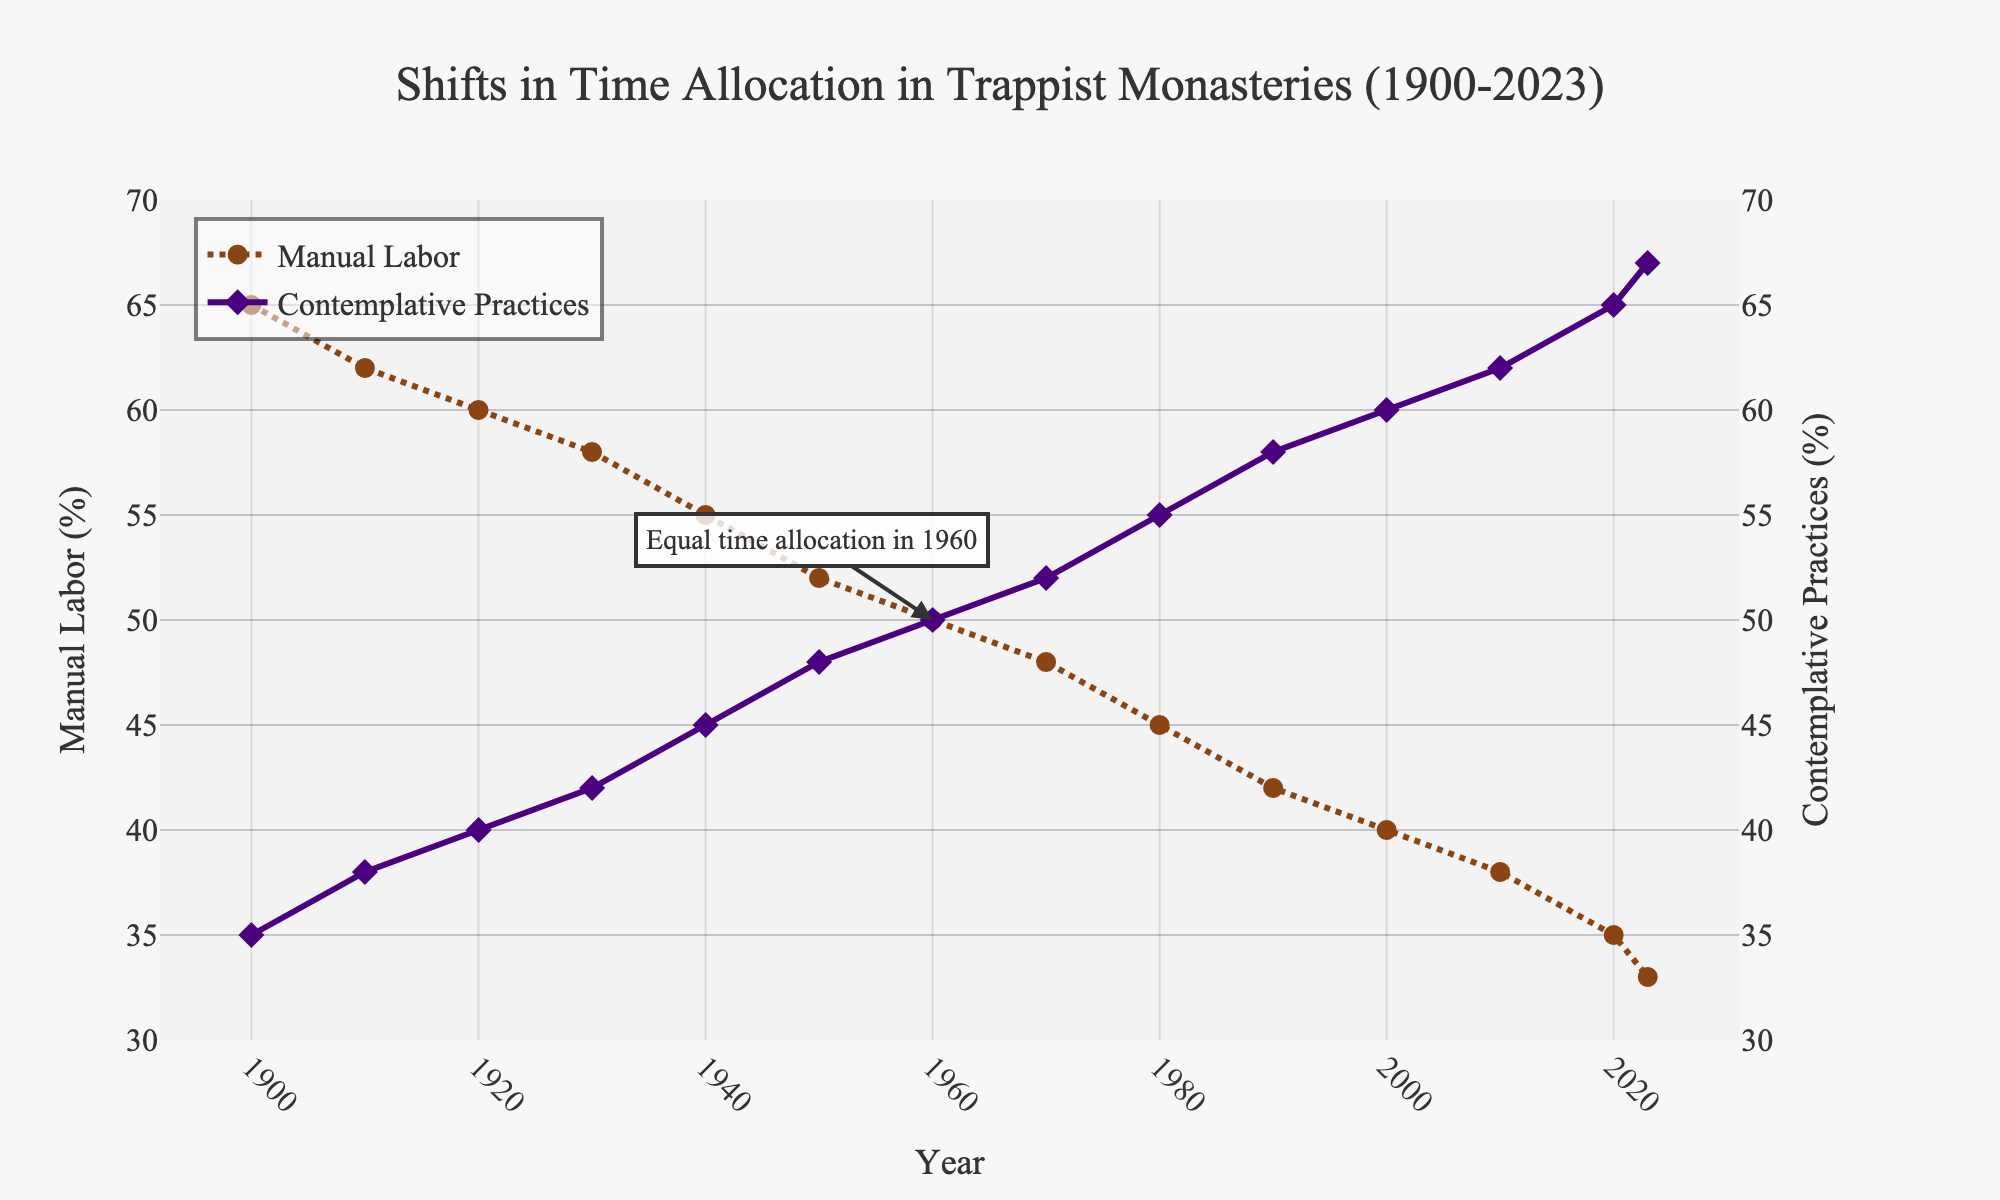What is the proportion of time allocated to manual labor in 1960? To find the proportion of time allocated to manual labor in 1960, look at the data point on the chart corresponding to the year 1960. The value is 50%.
Answer: 50% Which year had the highest proportion of time allocated to contemplative practices? To determine the year with the highest proportion of time allocated to contemplative practices, find the highest point on the purple line representing contemplative practices. The peak occurs in 2023 with 67%.
Answer: 2023 How did the proportion of time allocated to manual labor change between 1900 and 2023? To evaluate the change, subtract the proportion of time allocated in 2023 from that in 1900. It decreased from 65% in 1900 to 33% in 2023.
Answer: It decreased by 32% What is the difference in the proportions of time allocated to contemplative practices between 1930 and 2020? First, find the values for contemplative practices in 1930 (42%) and in 2020 (65%). Then, subtract the former from the latter: 65% - 42% = 23%.
Answer: 23% Which activity had more time allocated to it in 1980, and by how much? In 1980, the proportion for manual labor was 45% and for contemplative practices, it was 55%. Comparing the two, contemplative practices had more time allocated by 10%.
Answer: Contemplative practices by 10% In which year did the proportion of time allocated to manual labor and contemplative practices equal each other, and what was the value? Look for the year where both lines intersect. The figure shows they intersect in 1960, and the value is 50% for both activities.
Answer: 1960, 50% By how much did the proportion of time allocated to contemplative practices increase from 2000 to 2023? First, find the values for 2000 (60%) and 2023 (67%) and then subtract: 67% - 60% = 7%.
Answer: 7% Which year had the greatest yearly reduction in time allocated to manual labor between consecutive decades? By looking at the steepest downward slope on the brown line, the largest reduction appears between 2000 and 2010. Check that it decreased from 40% to 38%, a reduction of 2%.
Answer: 2000 to 2010 What is the average proportion of time allocated to contemplative practices from 1900 to 1950? Find the values for 1900 (35%), 1910 (38%), 1920 (40%), 1930 (42%), 1940 (45%), and 1950 (48%). Add these values and divide by 6: (35 + 38 + 40 + 42 + 45 + 48) / 6 = 41.33%.
Answer: 41.33% Which trace represents manual labor in the figure, and what are its visual characteristics? The trace representing manual labor is the brown line with dotted dashes, noticeable with circle markers. This line shows the decrease over time.
Answer: The brown dotted line with circles 